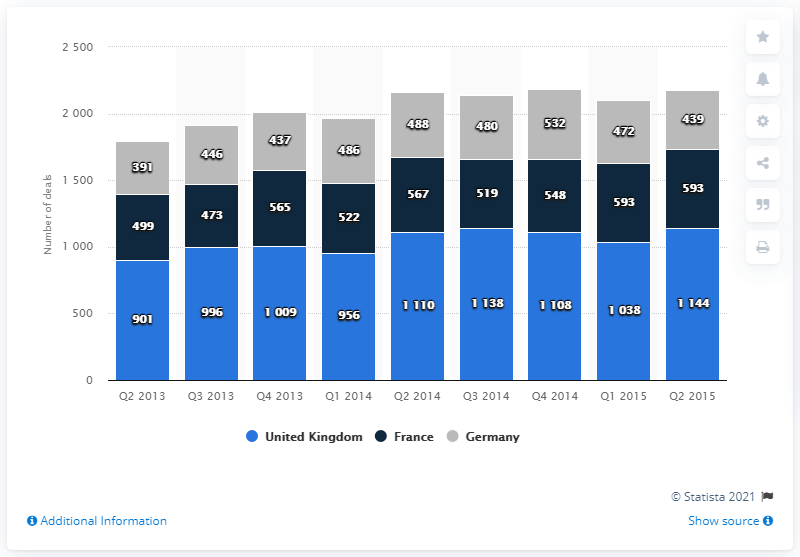List a handful of essential elements in this visual. The difference between the highest value in Q2 2015 and the lowest value in Q1 2015 is 672. The graph depicts three countries. 